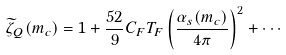Convert formula to latex. <formula><loc_0><loc_0><loc_500><loc_500>\widetilde { \zeta } _ { Q } ( m _ { c } ) = 1 + \frac { 5 2 } { 9 } C _ { F } T _ { F } \left ( \frac { \alpha _ { s } ( m _ { c } ) } { 4 \pi } \right ) ^ { 2 } + \cdots</formula> 